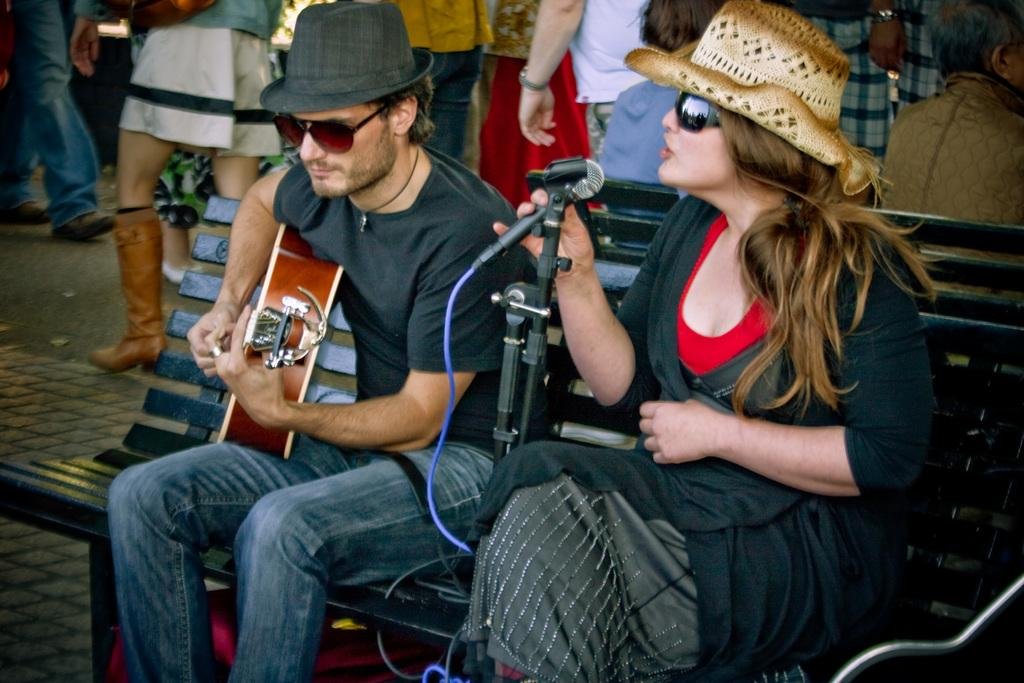What is the woman doing in the image? The woman is sitting on a bench and singing with a mic in her hand. What is the man doing beside the woman? The man is playing a guitar. Can you describe the man's appearance? The man is wearing a hat and goggles. Are there any other people in the image? Yes, there are people behind the woman and the man. What time is it according to the hour displayed on the woman's wrist? There is no hour displayed on the woman's wrist in the image. How many rings is the man wearing on his fingers? There is no mention of rings in the image, and the man's fingers are not visible. What type of chalk is the woman using to write on the ground? There is no chalk present in the image, and the woman is not writing on the ground. 